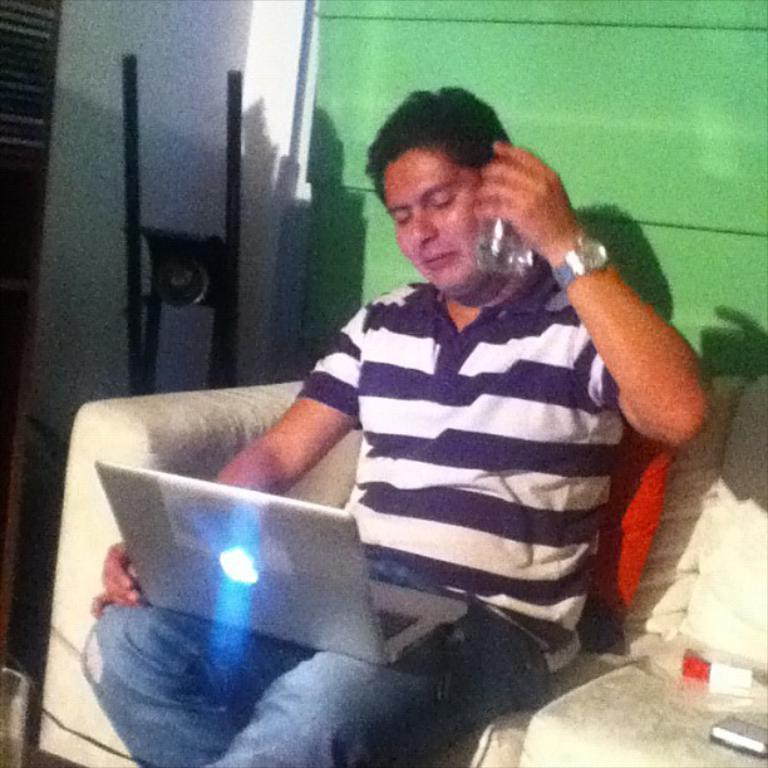Who is present in the image? There is a man in the image. What is the man doing in the image? The man is sitting on a sofa. What object is the man holding or using in the image? The man has a laptop on his lap. What can be seen in the background of the image? There is a wall in the background of the image. How many balloons are floating above the man's head in the image? There are no balloons present in the image. What type of building can be seen in the background of the image? The image does not show a building in the background; it only shows a wall. 